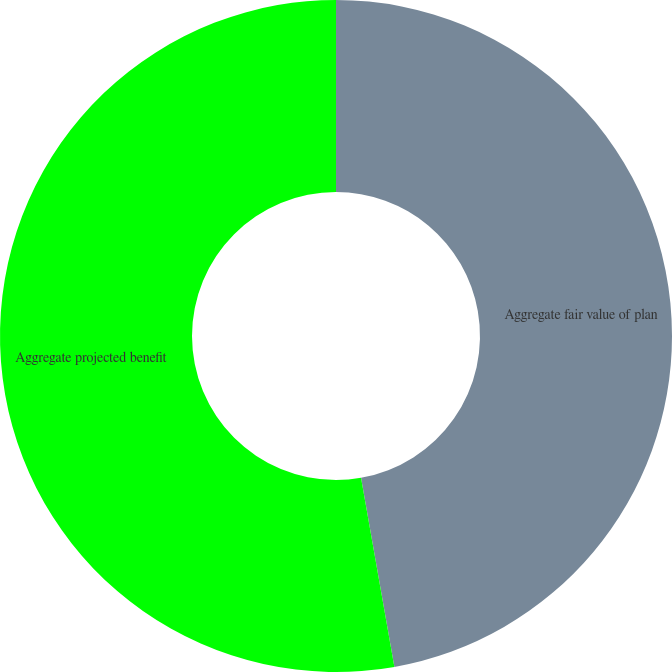Convert chart. <chart><loc_0><loc_0><loc_500><loc_500><pie_chart><fcel>Aggregate fair value of plan<fcel>Aggregate projected benefit<nl><fcel>47.22%<fcel>52.78%<nl></chart> 